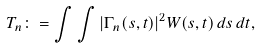Convert formula to latex. <formula><loc_0><loc_0><loc_500><loc_500>T _ { n } \colon = \int \int | \Gamma _ { n } ( s , t ) | ^ { 2 } W ( s , t ) \, d s \, d t ,</formula> 